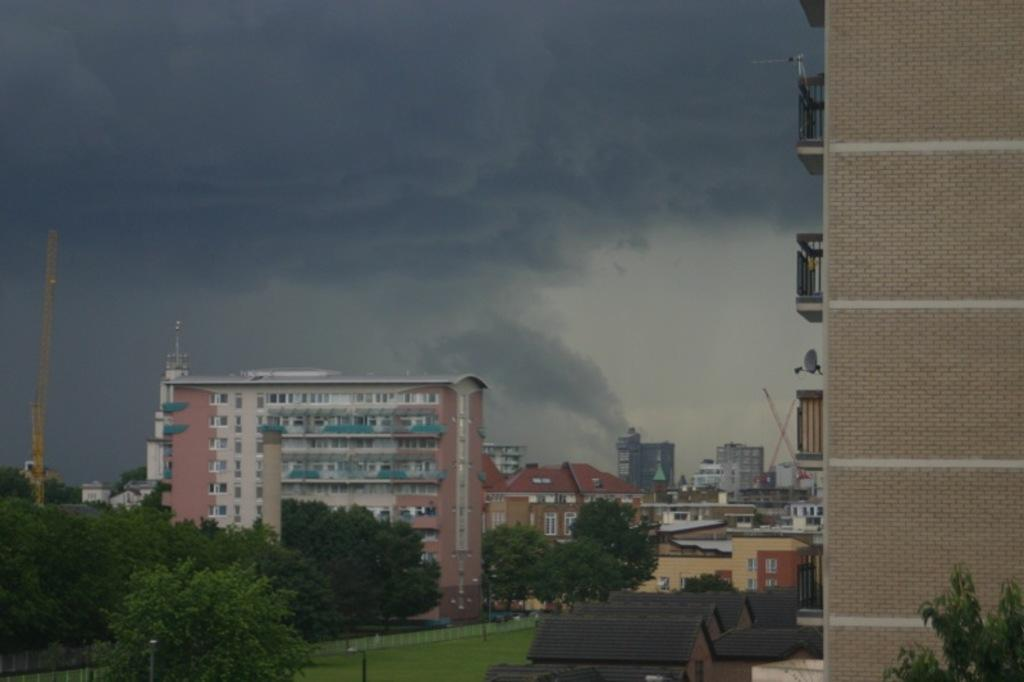What type of structures can be seen in the image? There are houses in the image. Where are the trees located in the image? The trees are on the left side of the image. What else can be seen in the background of the image? There are buildings in the background of the image. What is visible in the sky in the background of the image? There are clouds visible in the sky in the background of the image. What type of iron is being used to shape the trees in the image? There is no iron present in the image, and the trees are not being shaped. 